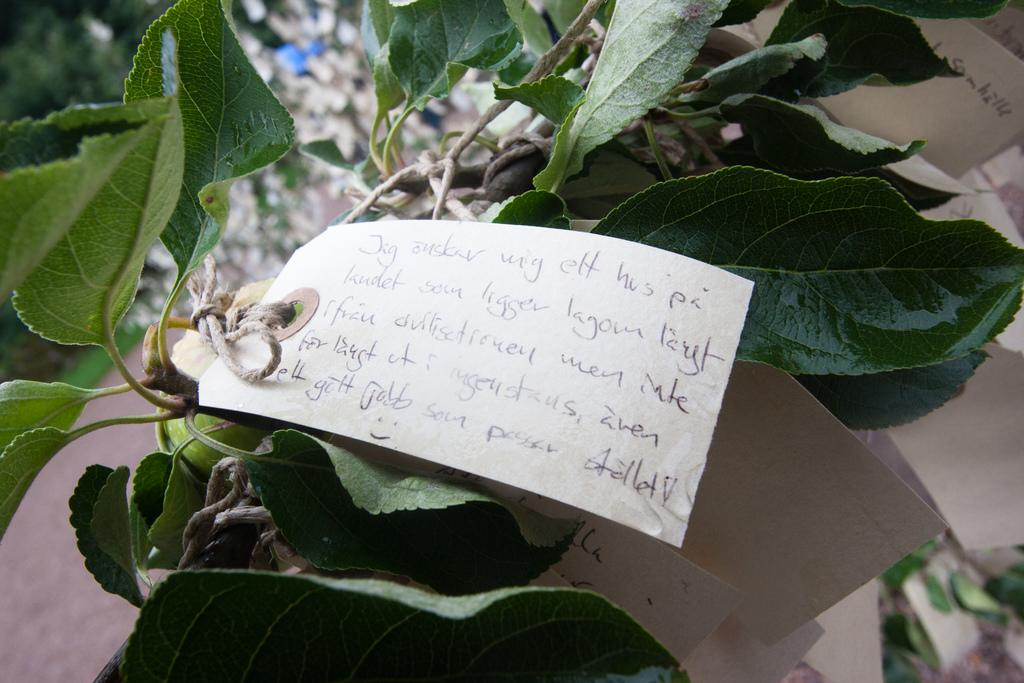What is attached to the plant in the image? There is a paper with text written on it in the image, and it is tied to the plant. Can you describe the paper in the image? The paper has text written on it, and it is tied to a plant. Reasoning: Let's think step by step by step in order to produce the conversation. We start by identifying the main subjects in the image, which are the paper and the plant. Then, we formulate questions that focus on the relationship between these subjects, ensuring that each question can be answered definitively with the information given. We avoid yes/no questions and ensure that the language is simple and clear. Absurd Question/Answer: What type of sea creature can be seen swimming near the plant in the image? There is no sea creature present in the image; it features a paper tied to a plant. What color is the crayon used to write on the paper in the image? There is no crayon mentioned in the image; the text on the paper is not described in terms of writing utensils. What type of plough is being used to cultivate the plant in the image? There is no plough present in the image; it features a paper tied to a plant. 